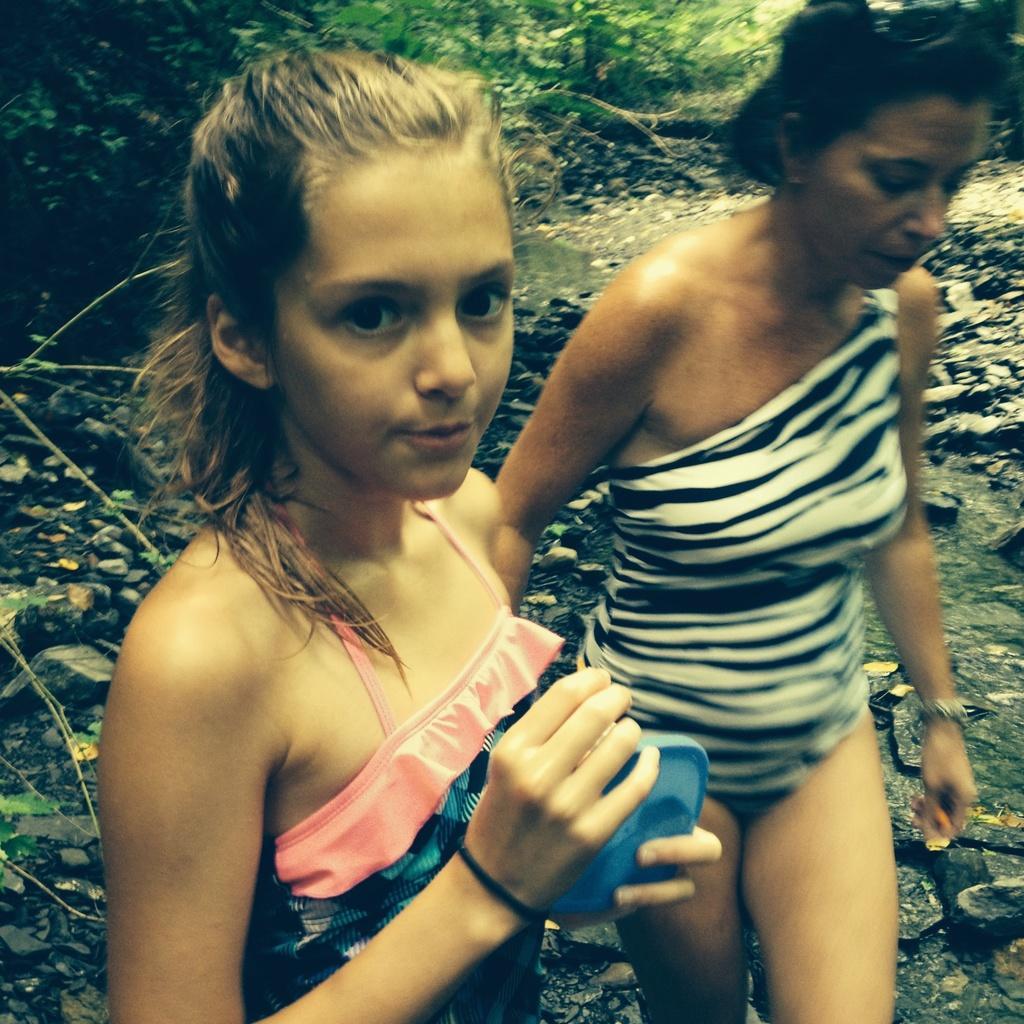Describe this image in one or two sentences. In this image we can see two persons. In the background we can see stones, water, and trees. 